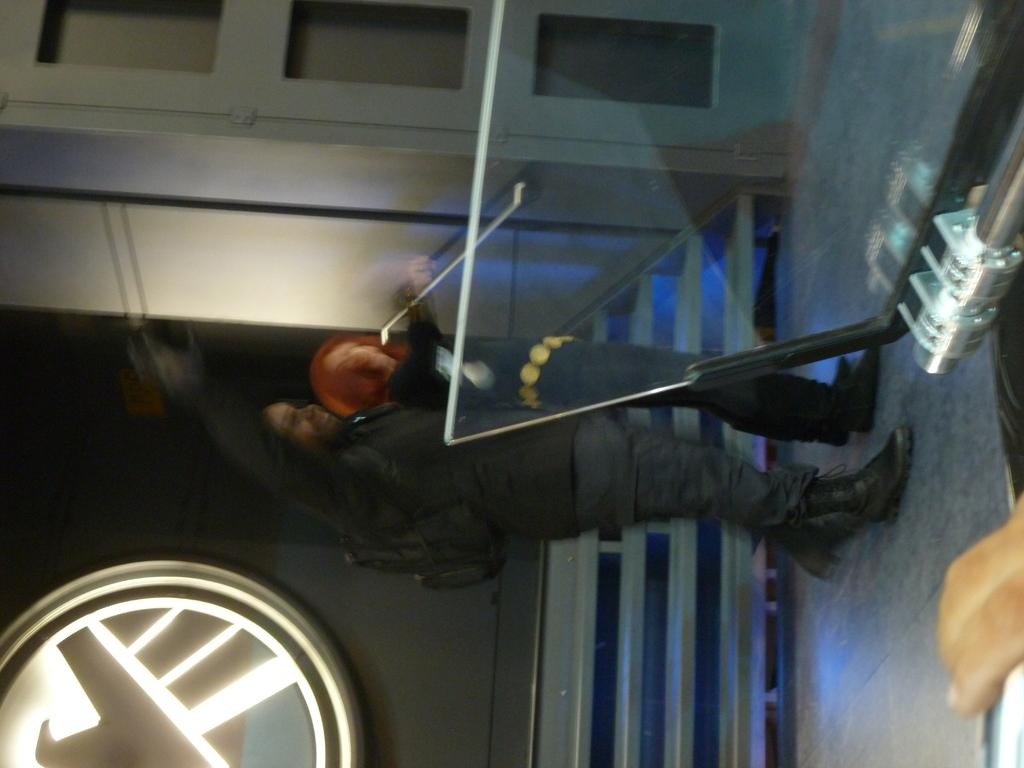Who is present in the image? There is a woman in the image. Where is the woman located in relation to the wall? The woman is standing near a wall in the image. What can be seen at the bottom of the image? There is railing visible at the bottom of the image. What object is on the right side of the image? There is a glass stand on the right side of the image. What architectural feature is visible at the top of the image? There is a door visible at the top of the image. What type of quartz can be seen growing on the wall in the image? There is no quartz present in the image, and therefore no such growth can be observed on the wall. 